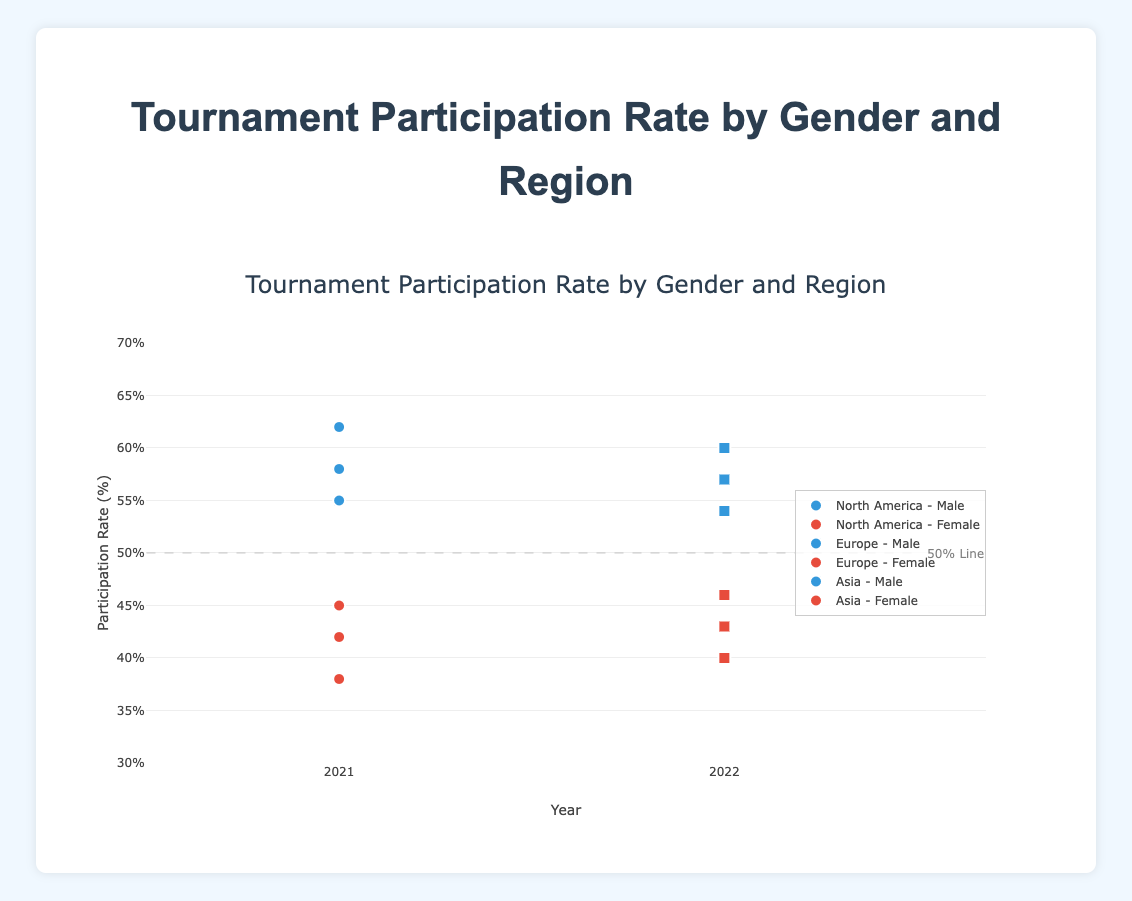What is the title of the figure? The title of the figure is displayed at the top in large, bold text.
Answer: Tournament Participation Rate by Gender and Region Which region had the highest male tournament participation rate in 2021? Looking at points for the year 2021, the highest male participation rate in the chart is for North America with 62%.
Answer: North America How does the female tournament participation rate in Europe change from 2021 to 2022? The scatter plot shows a point for 2021 with a 45% rate and a point for 2022 with a 46% rate for Europe Female group, indicating an increase.
Answer: It increases Compare the tournament participation rate of males in Asia and Europe for 2022. Which region has the higher rate? By comparing the y-axis values for Male in 2022, we see Asia has a rate of 57% and Europe has a rate of 54%.
Answer: Asia How many distinct gender categories are represented in the plot? The legend highlights two colors for the points, which correspond to 'Male' and 'Female' categories.
Answer: 2 In which region did the female participation rate decrease from 2021 to 2022? By checking the female points across years, only North America shows a decrease from 38% to 40%.
Answer: None (all increased) What is the average male tournament participation rate across all regions for the year 2021? To find the average, sum the 2021 male rates: 62 (NA) + 55 (E) + 58 (A) = 175. Then divide by 3. 175/3 = ~58.33
Answer: ~58.33% Which region and gender show the lowest participation rate in 2021? By examining the lowest point in 2021 on the scatter plot, it is North America Female at 38%.
Answer: North America Female Is there any region where the male participation rate was exactly the same in both 2021 and 2022? By comparing the male rates' values for both years in each region, none of them are the same in both years.
Answer: No What percentage is indicated by the line marked "50% Line"? The line is labeled "50% Line" at the annotation in the chart, indicating a participation rate of 50%.
Answer: 50% 